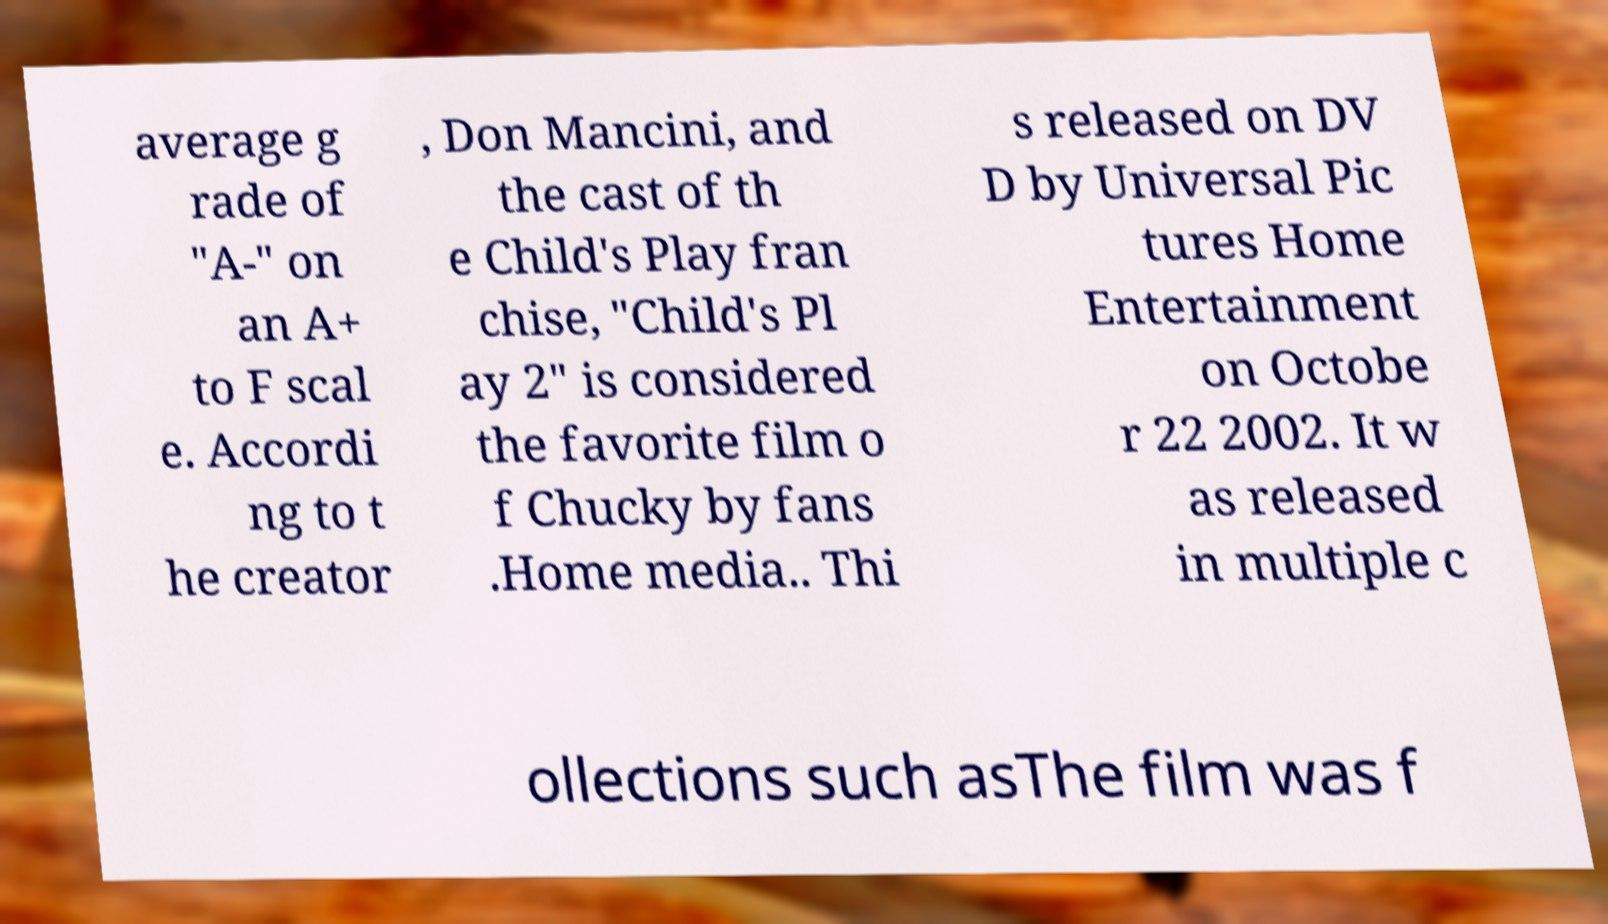For documentation purposes, I need the text within this image transcribed. Could you provide that? average g rade of "A-" on an A+ to F scal e. Accordi ng to t he creator , Don Mancini, and the cast of th e Child's Play fran chise, "Child's Pl ay 2" is considered the favorite film o f Chucky by fans .Home media.. Thi s released on DV D by Universal Pic tures Home Entertainment on Octobe r 22 2002. It w as released in multiple c ollections such asThe film was f 